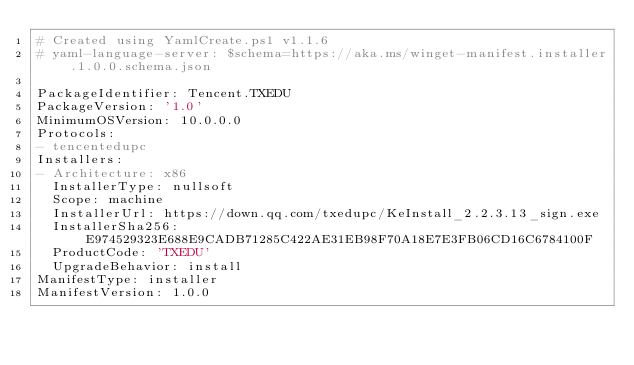<code> <loc_0><loc_0><loc_500><loc_500><_YAML_># Created using YamlCreate.ps1 v1.1.6
# yaml-language-server: $schema=https://aka.ms/winget-manifest.installer.1.0.0.schema.json

PackageIdentifier: Tencent.TXEDU
PackageVersion: '1.0'
MinimumOSVersion: 10.0.0.0
Protocols:
- tencentedupc
Installers:
- Architecture: x86
  InstallerType: nullsoft
  Scope: machine
  InstallerUrl: https://down.qq.com/txedupc/KeInstall_2.2.3.13_sign.exe
  InstallerSha256: E974529323E688E9CADB71285C422AE31EB98F70A18E7E3FB06CD16C6784100F
  ProductCode: 'TXEDU'
  UpgradeBehavior: install
ManifestType: installer
ManifestVersion: 1.0.0

</code> 